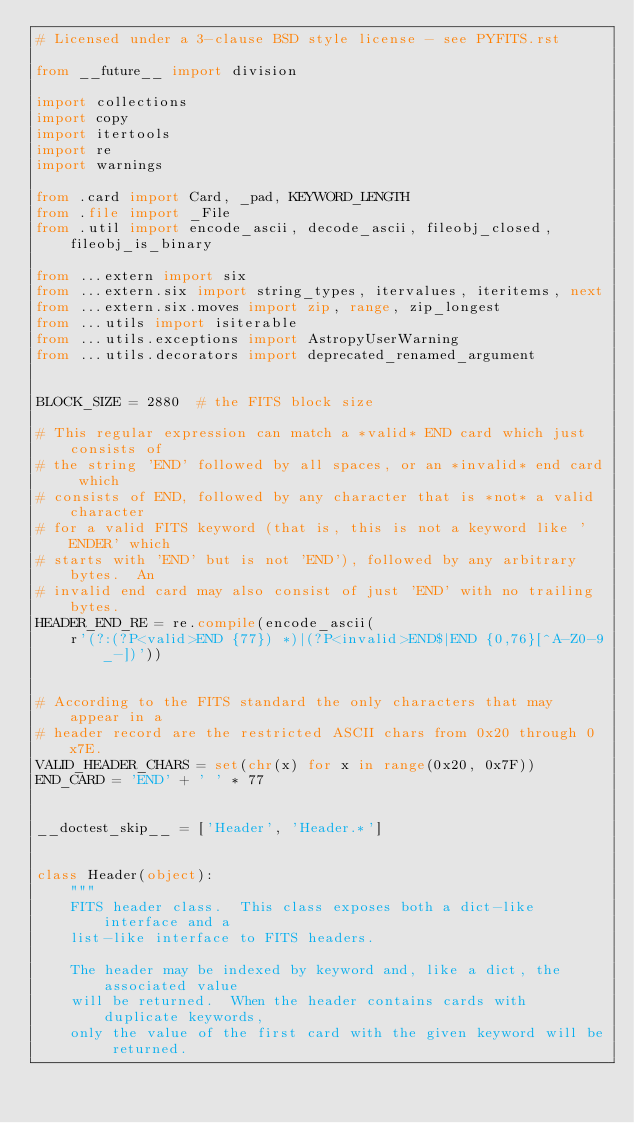Convert code to text. <code><loc_0><loc_0><loc_500><loc_500><_Python_># Licensed under a 3-clause BSD style license - see PYFITS.rst

from __future__ import division

import collections
import copy
import itertools
import re
import warnings

from .card import Card, _pad, KEYWORD_LENGTH
from .file import _File
from .util import encode_ascii, decode_ascii, fileobj_closed, fileobj_is_binary

from ...extern import six
from ...extern.six import string_types, itervalues, iteritems, next
from ...extern.six.moves import zip, range, zip_longest
from ...utils import isiterable
from ...utils.exceptions import AstropyUserWarning
from ...utils.decorators import deprecated_renamed_argument


BLOCK_SIZE = 2880  # the FITS block size

# This regular expression can match a *valid* END card which just consists of
# the string 'END' followed by all spaces, or an *invalid* end card which
# consists of END, followed by any character that is *not* a valid character
# for a valid FITS keyword (that is, this is not a keyword like 'ENDER' which
# starts with 'END' but is not 'END'), followed by any arbitrary bytes.  An
# invalid end card may also consist of just 'END' with no trailing bytes.
HEADER_END_RE = re.compile(encode_ascii(
    r'(?:(?P<valid>END {77}) *)|(?P<invalid>END$|END {0,76}[^A-Z0-9_-])'))


# According to the FITS standard the only characters that may appear in a
# header record are the restricted ASCII chars from 0x20 through 0x7E.
VALID_HEADER_CHARS = set(chr(x) for x in range(0x20, 0x7F))
END_CARD = 'END' + ' ' * 77


__doctest_skip__ = ['Header', 'Header.*']


class Header(object):
    """
    FITS header class.  This class exposes both a dict-like interface and a
    list-like interface to FITS headers.

    The header may be indexed by keyword and, like a dict, the associated value
    will be returned.  When the header contains cards with duplicate keywords,
    only the value of the first card with the given keyword will be returned.</code> 